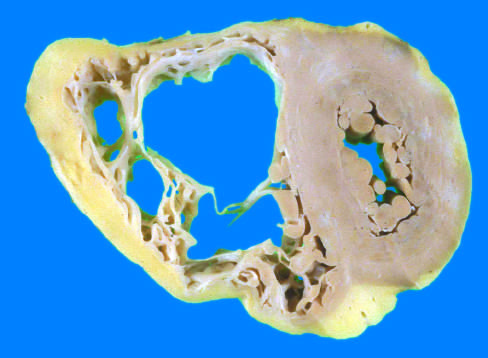does the injurious stimulus have a grossly normal appearance in this heart?
Answer the question using a single word or phrase. No 